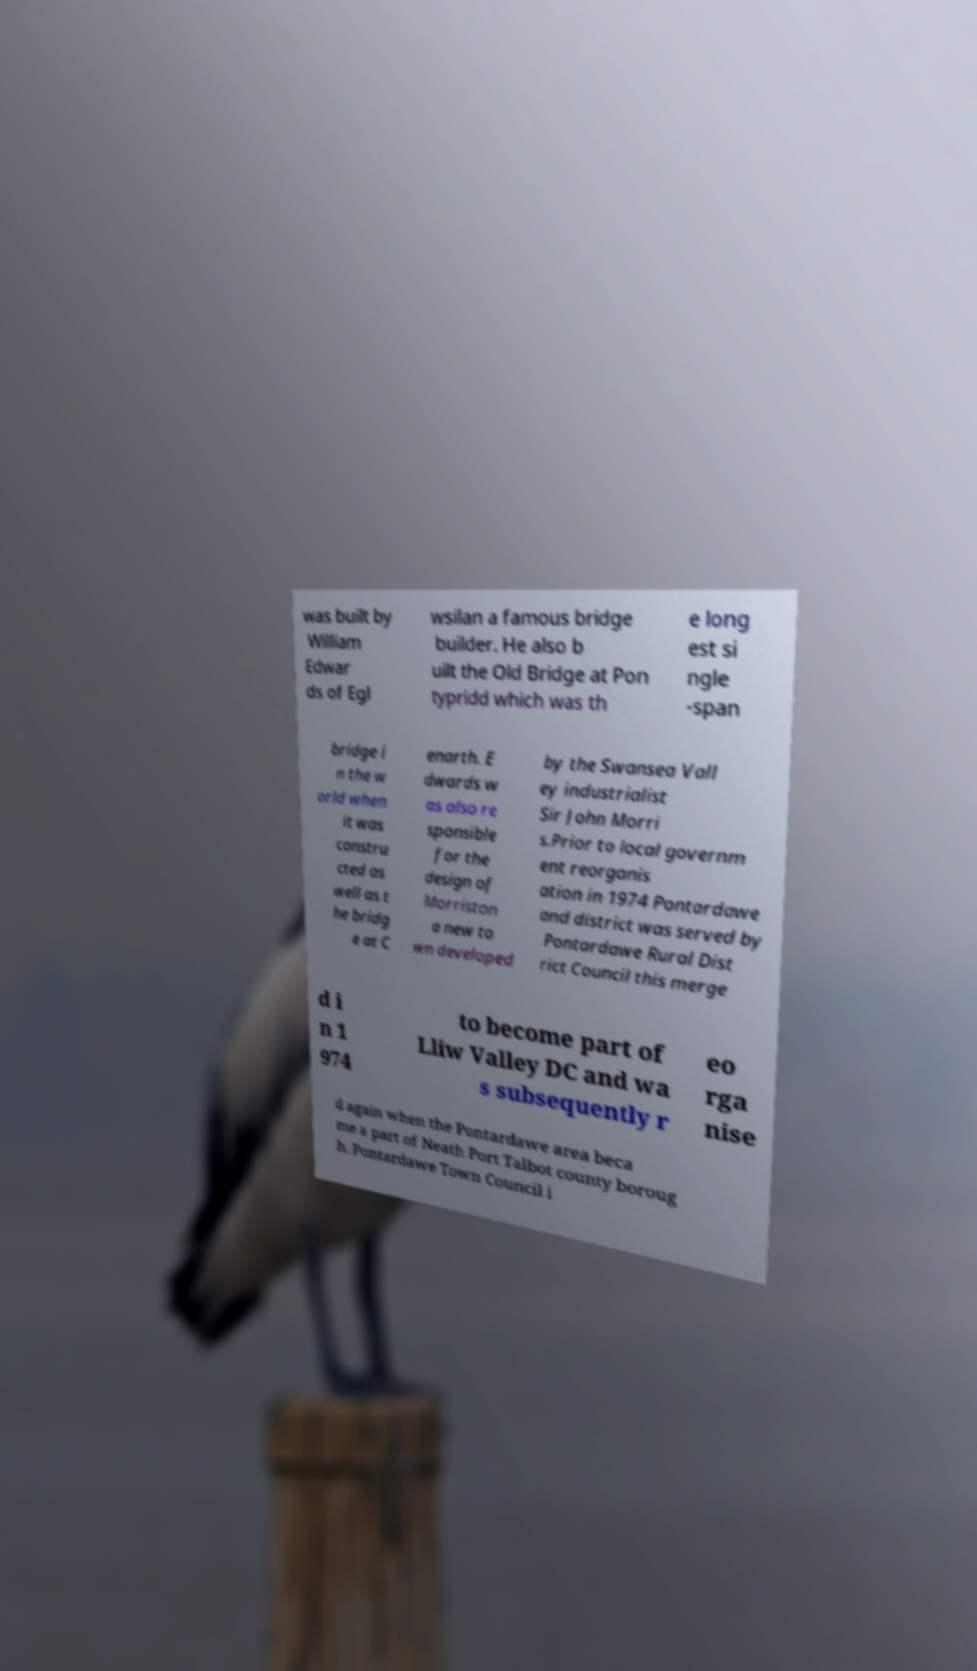There's text embedded in this image that I need extracted. Can you transcribe it verbatim? was built by William Edwar ds of Egl wsilan a famous bridge builder. He also b uilt the Old Bridge at Pon typridd which was th e long est si ngle -span bridge i n the w orld when it was constru cted as well as t he bridg e at C enarth. E dwards w as also re sponsible for the design of Morriston a new to wn developed by the Swansea Vall ey industrialist Sir John Morri s.Prior to local governm ent reorganis ation in 1974 Pontardawe and district was served by Pontardawe Rural Dist rict Council this merge d i n 1 974 to become part of Lliw Valley DC and wa s subsequently r eo rga nise d again when the Pontardawe area beca me a part of Neath Port Talbot county boroug h. Pontardawe Town Council i 